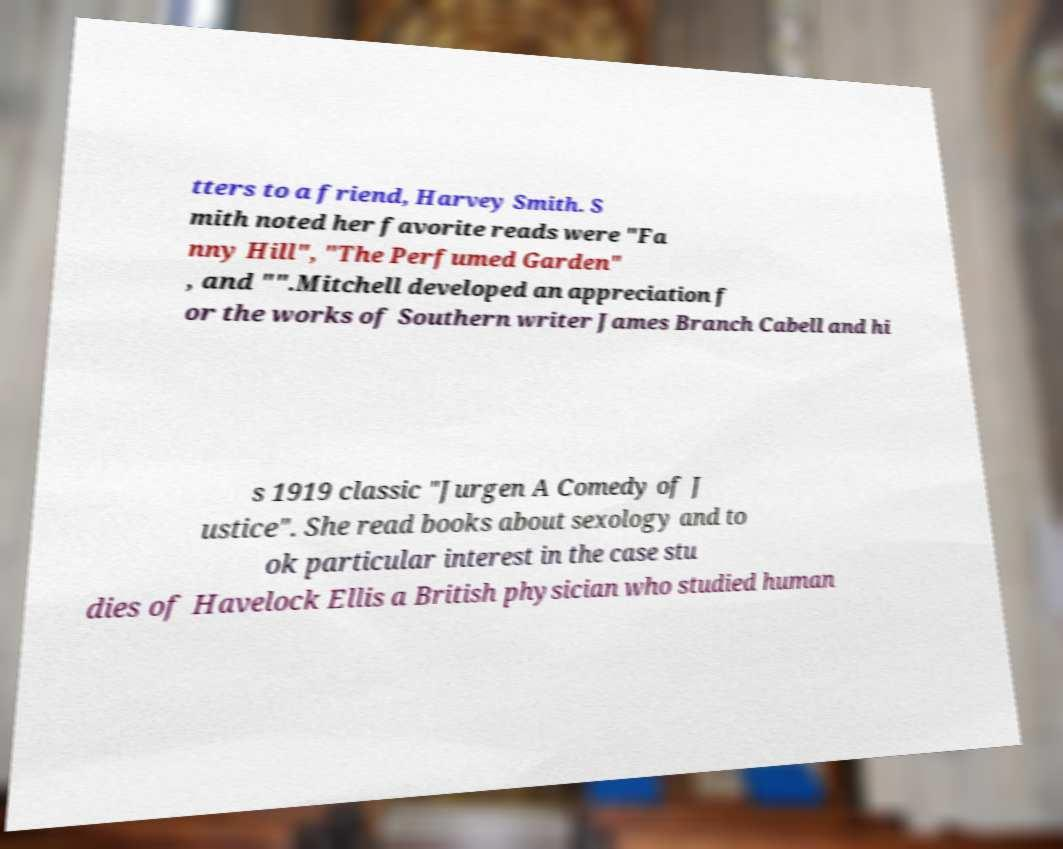Can you read and provide the text displayed in the image?This photo seems to have some interesting text. Can you extract and type it out for me? tters to a friend, Harvey Smith. S mith noted her favorite reads were "Fa nny Hill", "The Perfumed Garden" , and "".Mitchell developed an appreciation f or the works of Southern writer James Branch Cabell and hi s 1919 classic "Jurgen A Comedy of J ustice". She read books about sexology and to ok particular interest in the case stu dies of Havelock Ellis a British physician who studied human 